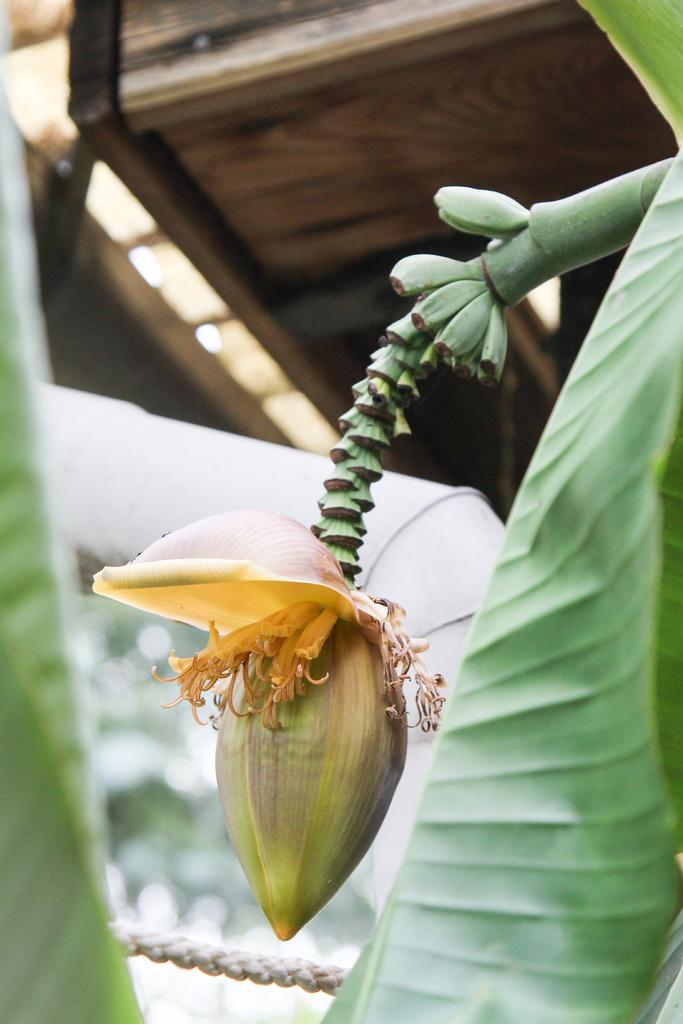What type of plant is featured in the image? There is a banana flower in the image. What is growing on the plant? There are bananas in the image. What other plant elements can be seen in the image? There are leaves in the image. What type of structure is visible in the background? There is a shed in the image. What type of card is being used to control the growth of the banana plant in the image? There is no card or control mechanism present in the image; it is a natural scene featuring a banana plant. What type of ornament is hanging from the banana flower in the image? There is no ornament present on the banana flower in the image; it is a natural plant. 